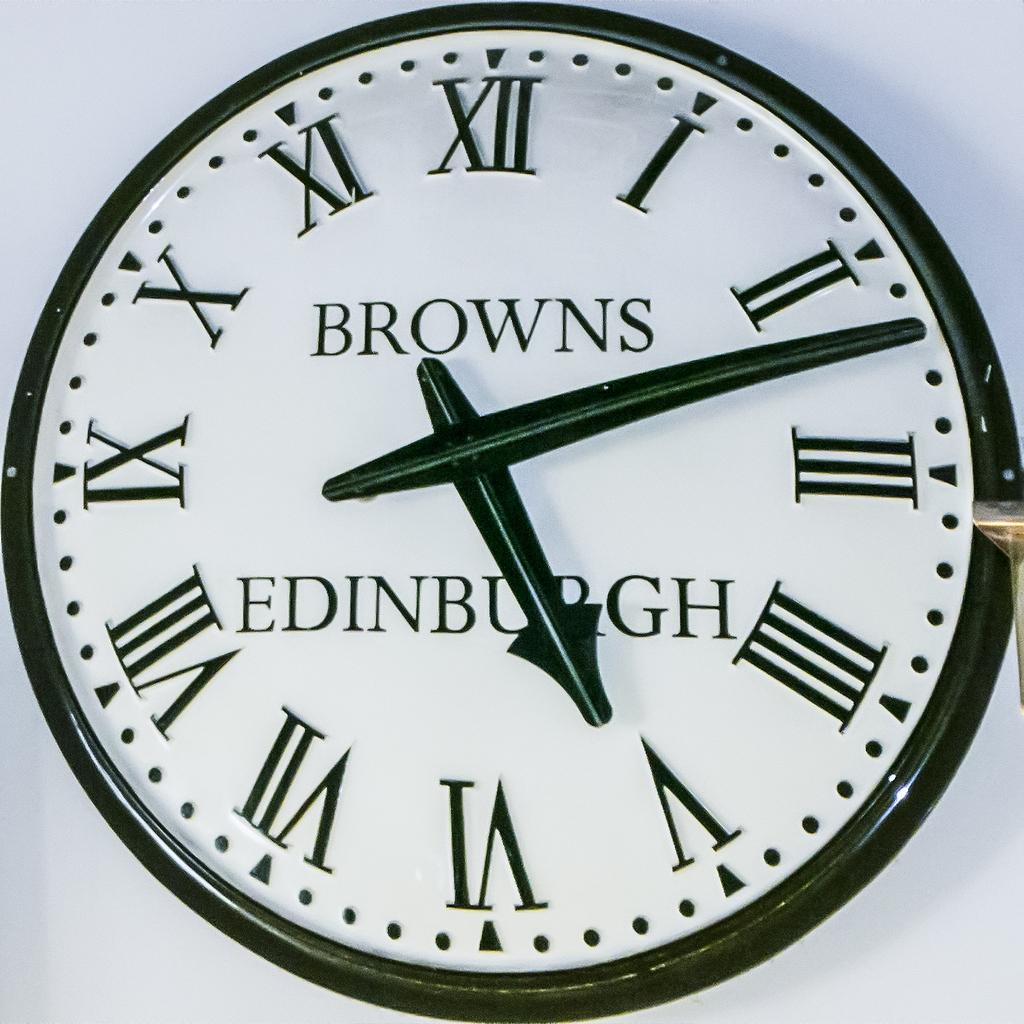Provide a one-sentence caption for the provided image. the word browns that is on a clock. 